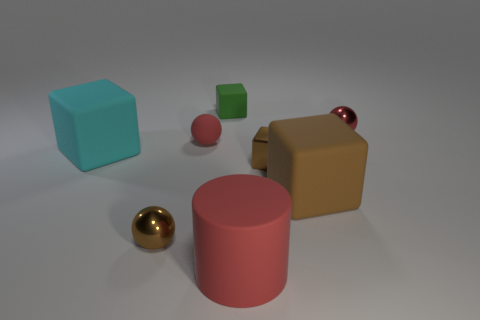How many metallic spheres are the same color as the cylinder?
Your answer should be very brief. 1. What size is the brown object that is the same material as the tiny green cube?
Make the answer very short. Large. The brown rubber thing that is the same shape as the green rubber thing is what size?
Give a very brief answer. Large. The small metal thing that is the same color as the shiny cube is what shape?
Give a very brief answer. Sphere. The large object on the left side of the green cube is what color?
Make the answer very short. Cyan. Is there a small green object of the same shape as the big red object?
Offer a terse response. No. Are there fewer small brown shiny spheres that are left of the cyan cube than tiny brown metal spheres to the right of the brown metal cube?
Keep it short and to the point. No. The tiny metal cube has what color?
Offer a terse response. Brown. There is a tiny shiny object that is left of the large red matte object; are there any big rubber blocks to the right of it?
Ensure brevity in your answer.  Yes. What number of cyan matte things have the same size as the red matte cylinder?
Keep it short and to the point. 1. 